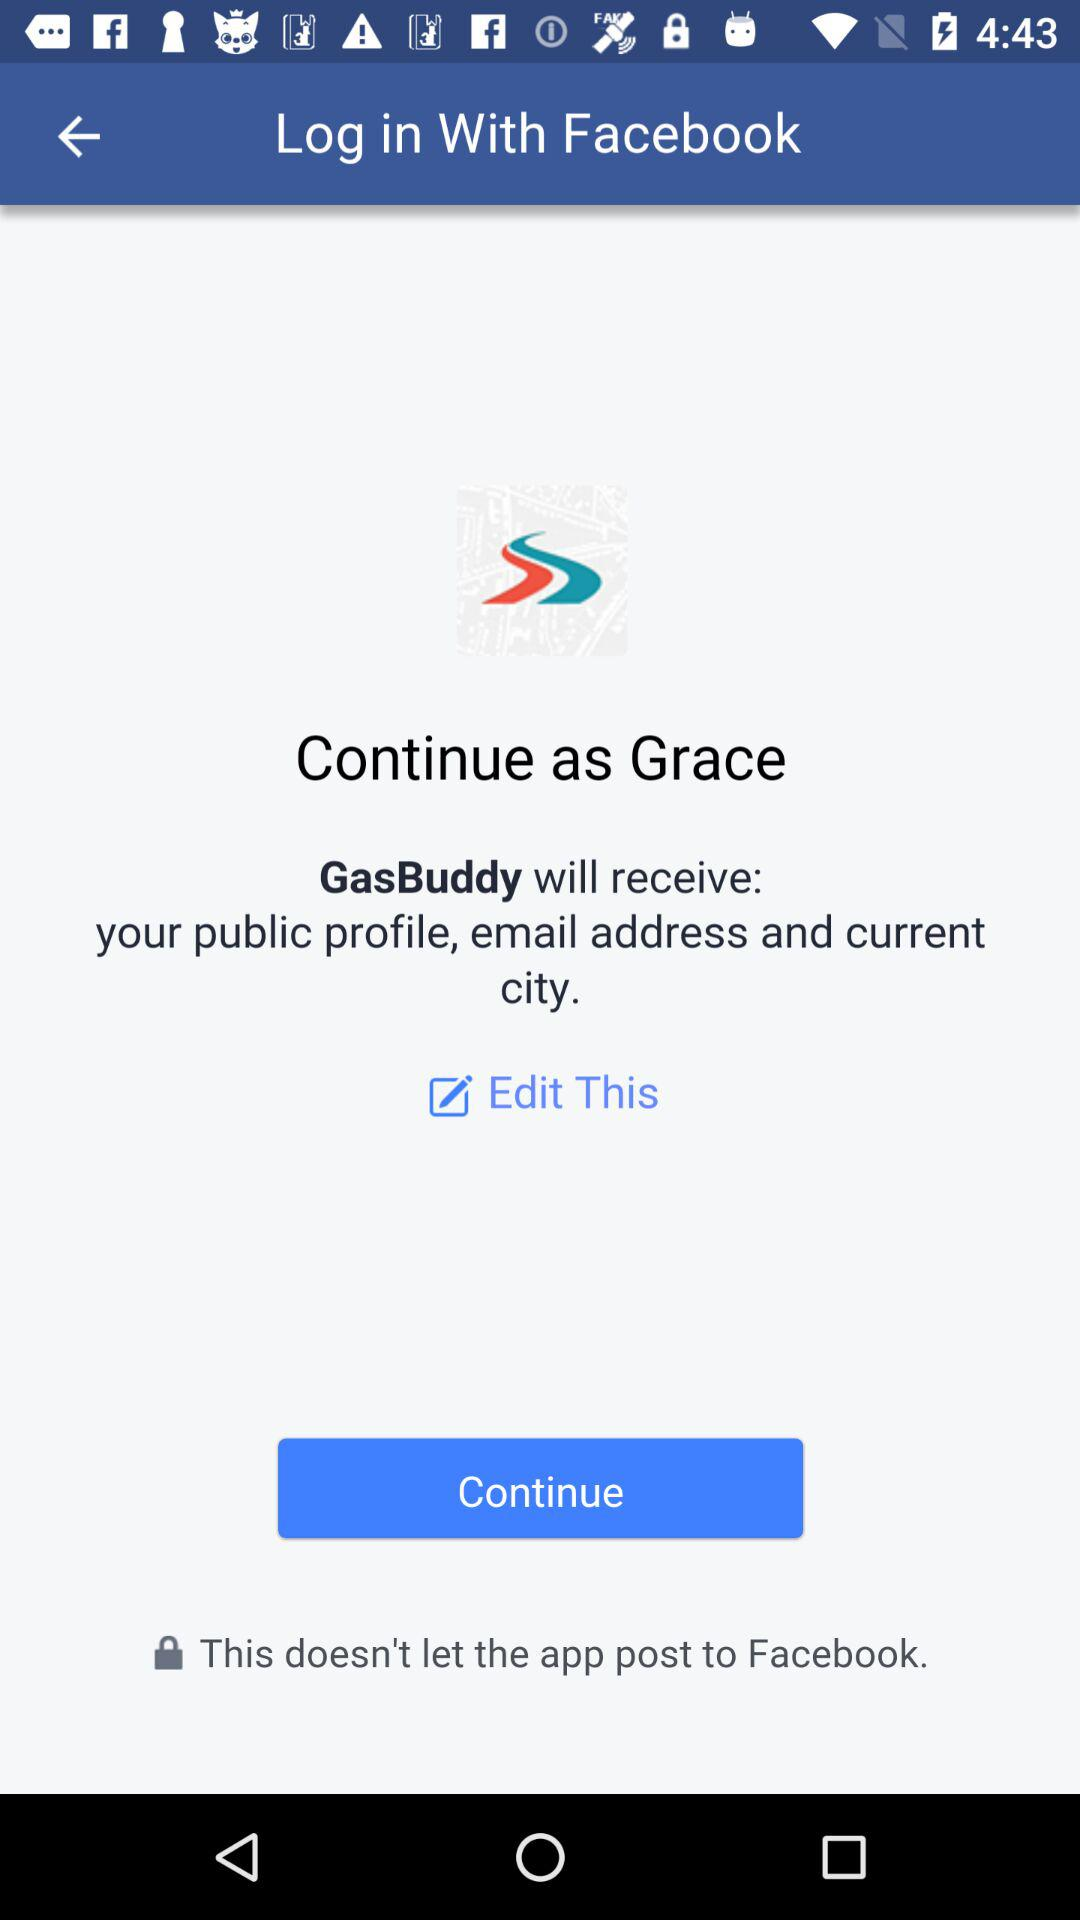When was this last edited?
When the provided information is insufficient, respond with <no answer>. <no answer> 